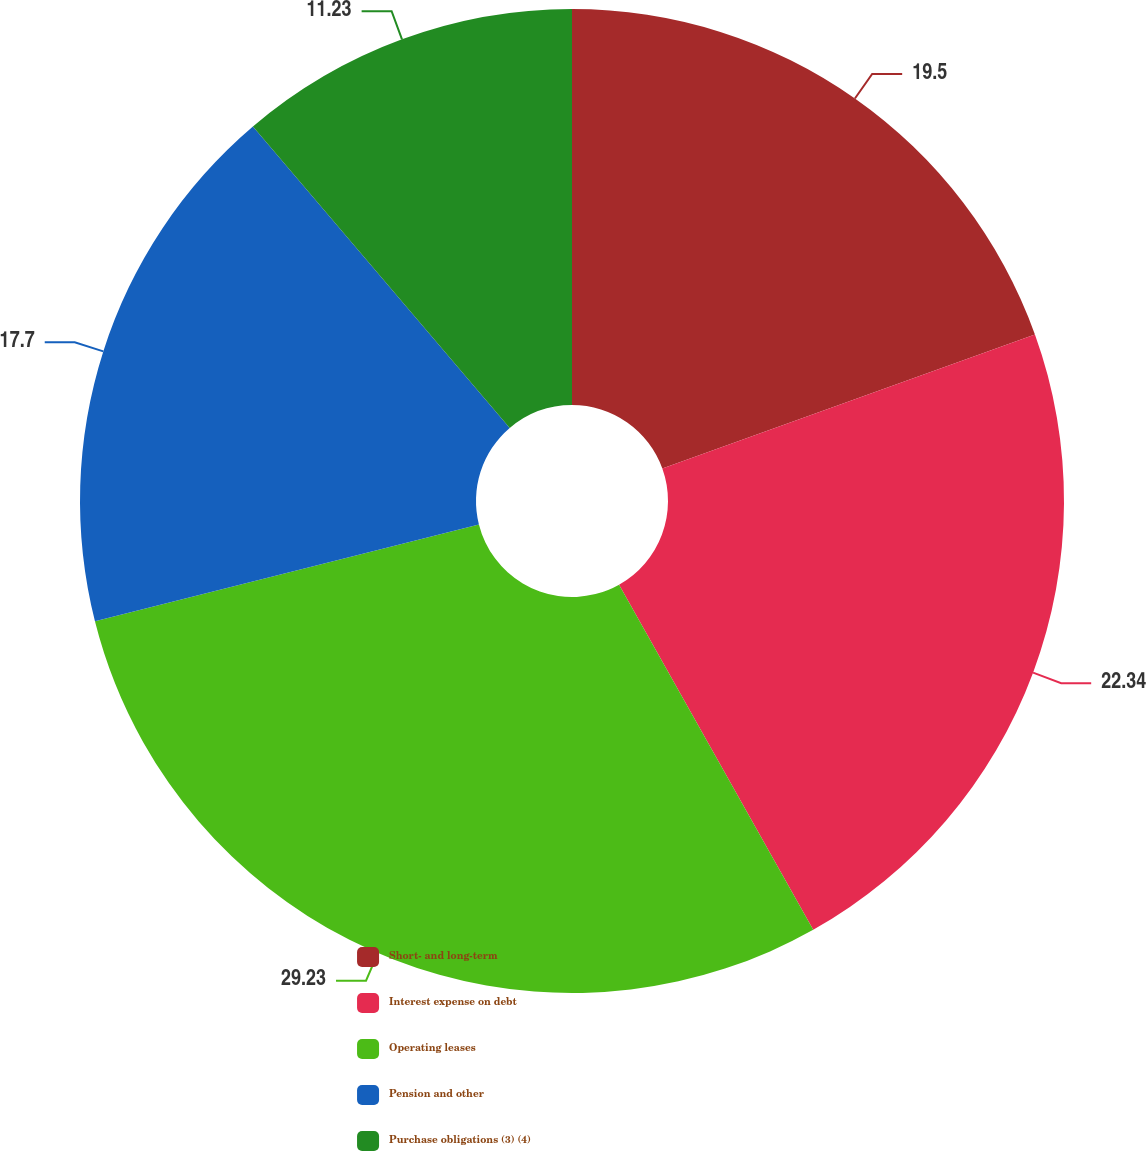Convert chart to OTSL. <chart><loc_0><loc_0><loc_500><loc_500><pie_chart><fcel>Short- and long-term<fcel>Interest expense on debt<fcel>Operating leases<fcel>Pension and other<fcel>Purchase obligations (3) (4)<nl><fcel>19.5%<fcel>22.34%<fcel>29.22%<fcel>17.7%<fcel>11.23%<nl></chart> 